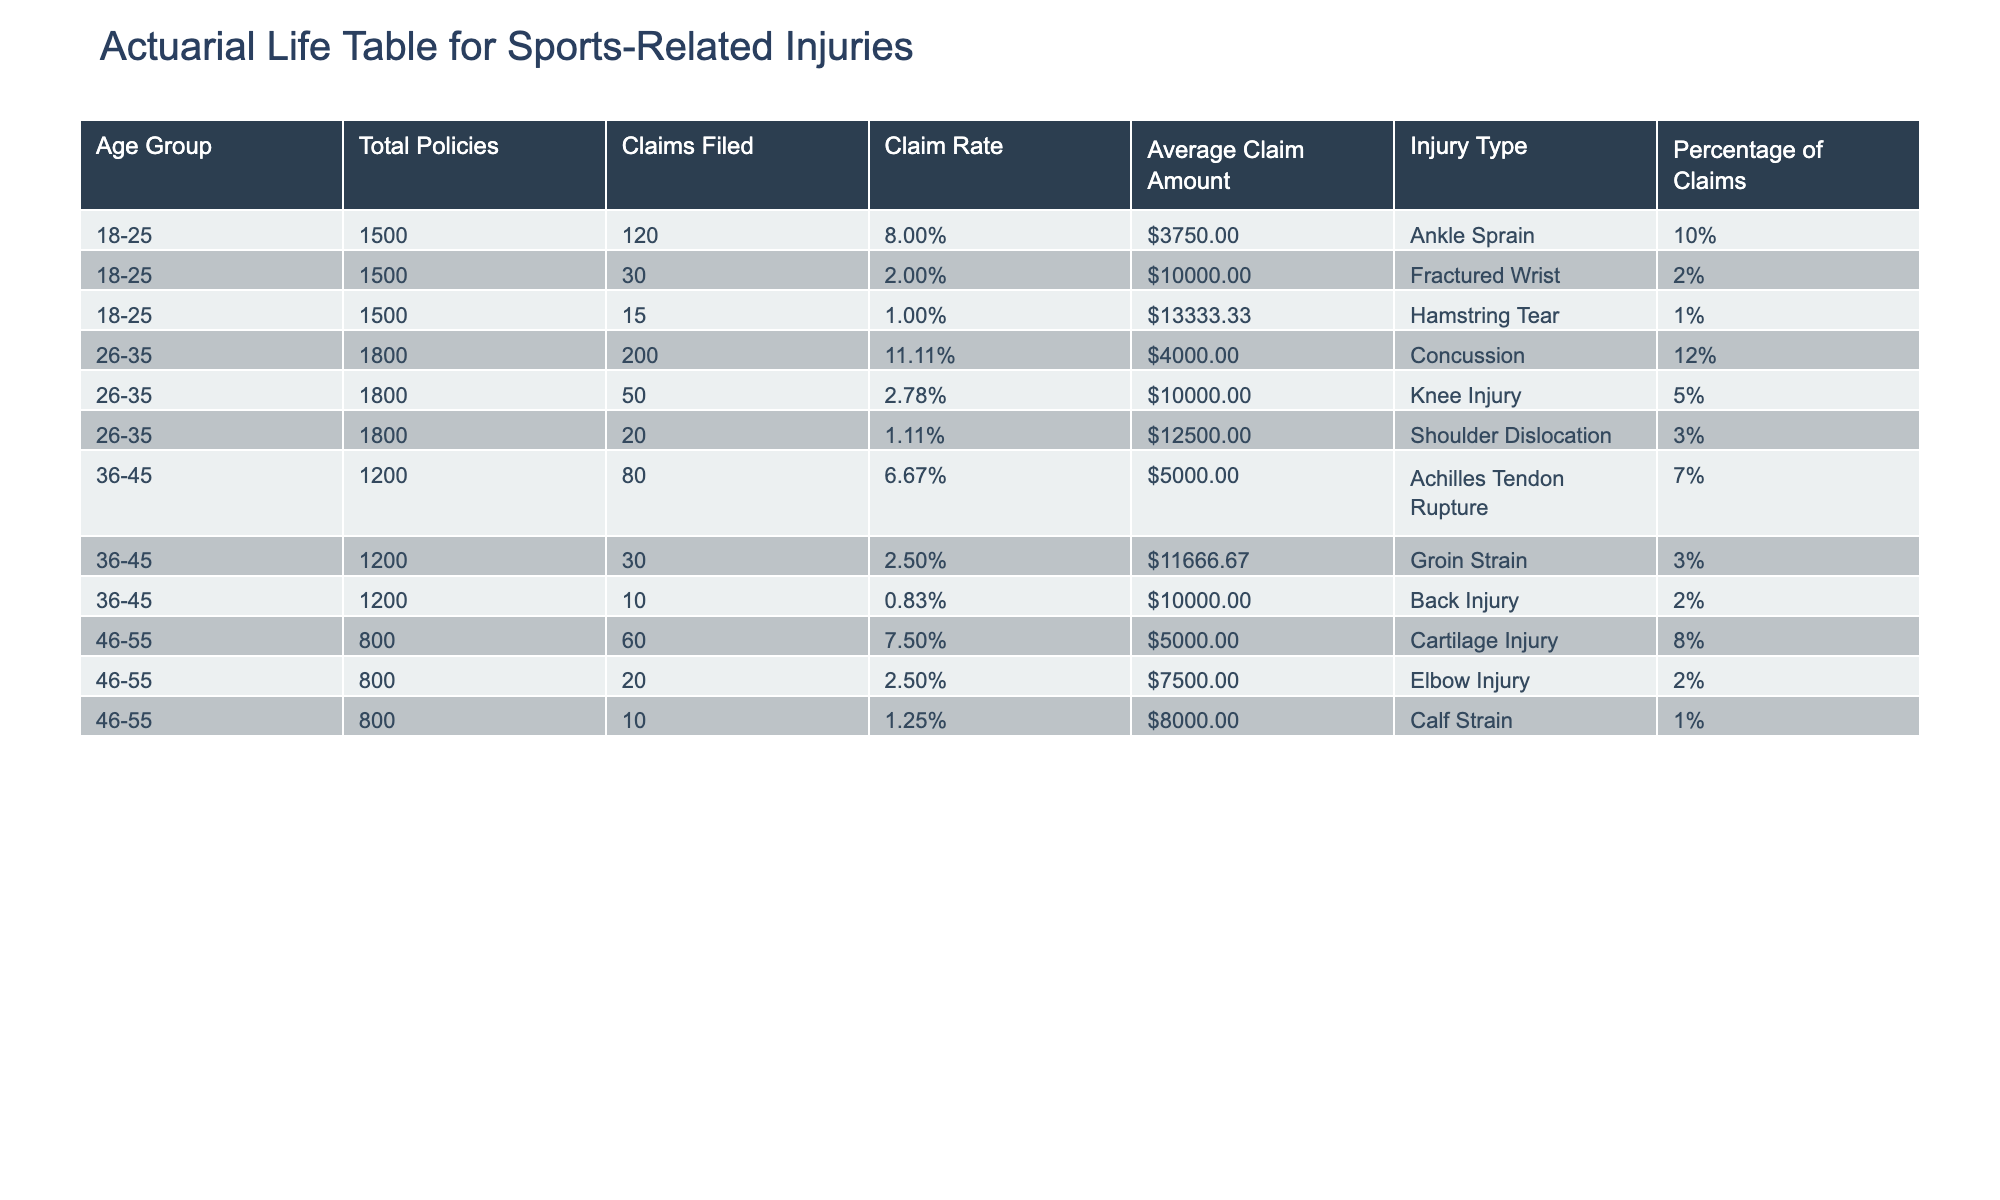What is the total amount claimed for ankle sprains in the 18-25 age group? In the 18-25 age group, the amount claimed for ankle sprains is shown in the table as 450,000 USD.
Answer: 450000 USD What is the claim rate for the 26-35 age group? The claim rate is calculated by dividing the number of claims filed (200) by the total policies (1800). Thus, the claim rate for this age group is 200/1800 = 0.1111 or 11.11%.
Answer: 11.11% Which injury type has the highest claim amount in the 36-45 age group? In the 36-45 age group, the highest claim amount is for the Achilles tendon rupture, which amounts to 400,000 USD, compared to groin strain (350,000 USD) and back injury (100,000 USD).
Answer: Achilles Tendon Rupture What percentage of claims in the 46-55 age group are due to cartilage injuries? The table shows that cartilage injuries account for 8% of the claims filed in the 46-55 age group.
Answer: 8% Are there more claims filed for knee injuries than shoulder dislocations in the 26-35 age group? The table shows that there are 50 claims filed for knee injuries and 20 for shoulder dislocations in the 26-35 age group. Thus, there are more claims for knee injuries than shoulder dislocations.
Answer: Yes What is the average claim amount for ankle sprains in the 18-25 age group? The average claim amount is found by dividing the claim amount (450,000 USD) by the number of claims filed (120). Therefore, the average claim amount for ankle sprains is 450,000 / 120 = 3750 USD.
Answer: 3750 USD What is the total number of claims filed across all age groups? To find the total claims, we sum the claims filed in each age group: 120 + 30 + 15 + 200 + 50 + 20 + 80 + 30 + 10 + 60 + 20 + 10 = 625.
Answer: 625 Which age group has the lowest average claim amount and what is it? To find the average claim amount for each age group, divide the total claim amount by the claims filed. The calculations are:  (450,000/120) for 18-25, (800,000/200) for 26-35, (400,000/80) for 36-45, (300,000/60) for 46-55. The lowest is for 46-55, which is 5000 USD.
Answer: 5000 USD 